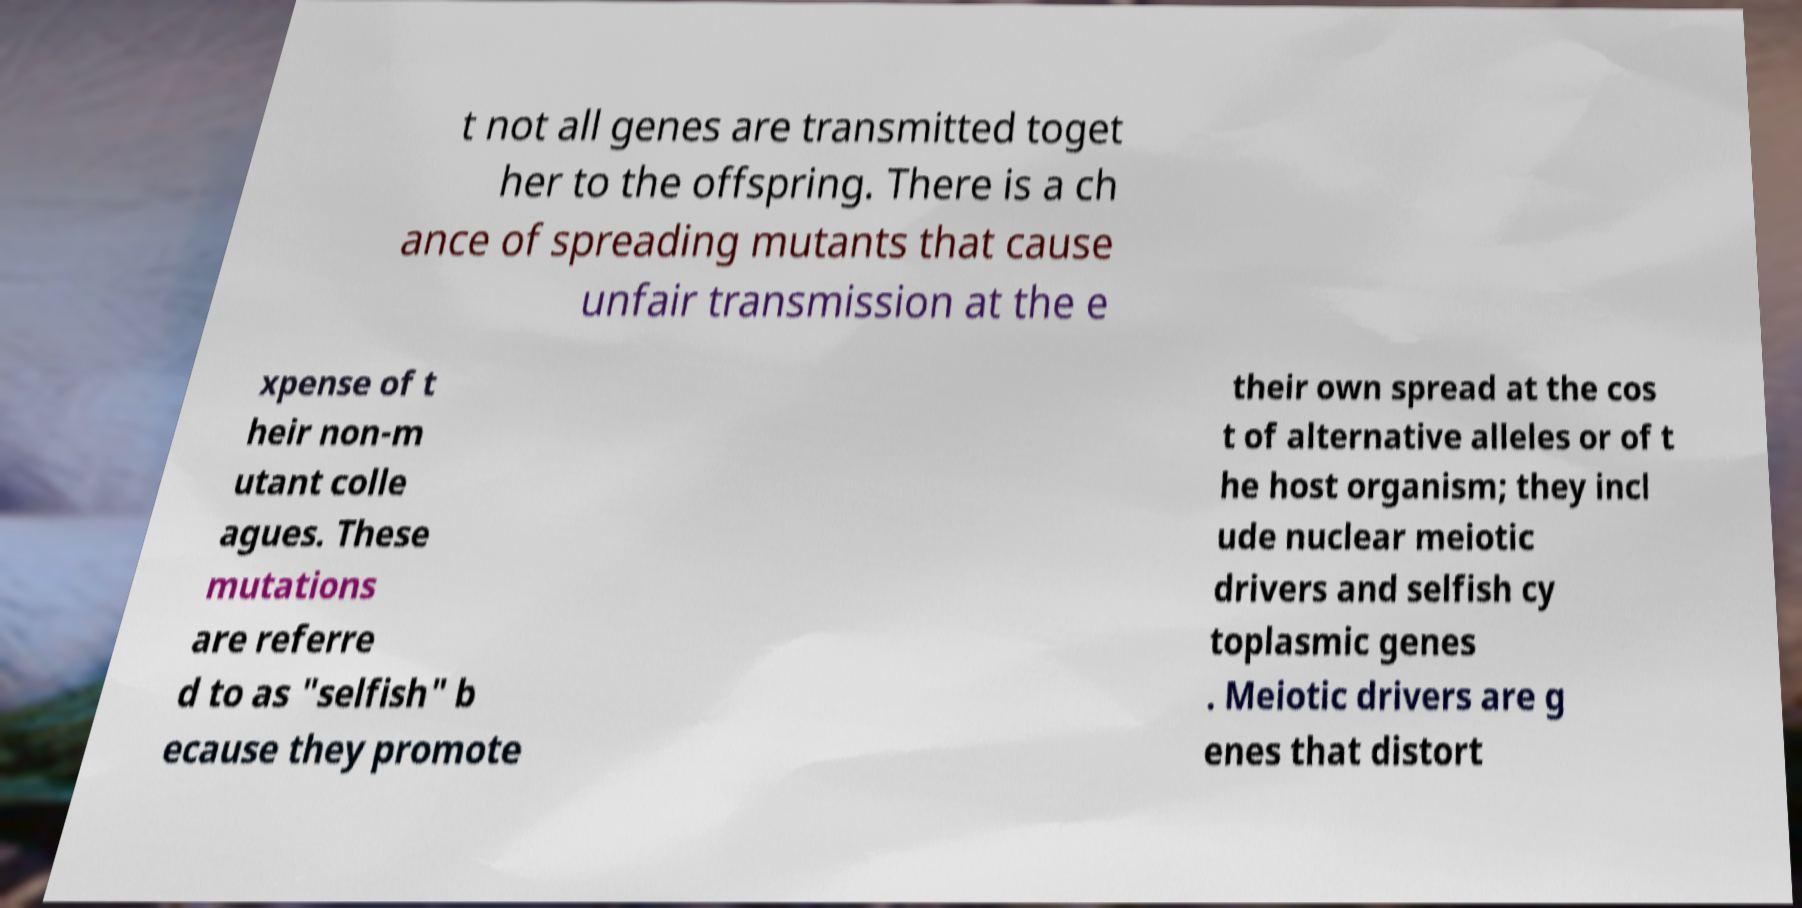For documentation purposes, I need the text within this image transcribed. Could you provide that? t not all genes are transmitted toget her to the offspring. There is a ch ance of spreading mutants that cause unfair transmission at the e xpense of t heir non-m utant colle agues. These mutations are referre d to as "selfish" b ecause they promote their own spread at the cos t of alternative alleles or of t he host organism; they incl ude nuclear meiotic drivers and selfish cy toplasmic genes . Meiotic drivers are g enes that distort 